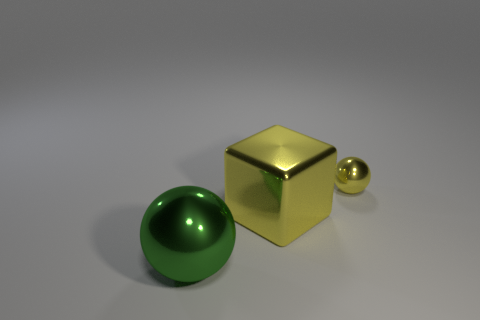How many other green shiny balls have the same size as the green sphere?
Provide a succinct answer. 0. Are there more blue cylinders than big things?
Give a very brief answer. No. Does the tiny yellow object have the same shape as the large green metallic object?
Your answer should be very brief. Yes. Is there any other thing that has the same shape as the large green metallic thing?
Keep it short and to the point. Yes. There is a metal object to the right of the yellow block; does it have the same color as the big metallic object behind the green sphere?
Provide a short and direct response. Yes. Is the number of large cubes that are left of the big green thing less than the number of metal spheres to the right of the metallic cube?
Give a very brief answer. Yes. There is a large yellow object that is to the left of the small yellow shiny object; what is its shape?
Your answer should be very brief. Cube. There is a small object that is the same color as the big block; what is its material?
Offer a terse response. Metal. There is a small thing; is it the same shape as the big object in front of the large block?
Offer a very short reply. Yes. There is a big yellow object that is the same material as the green object; what is its shape?
Your answer should be compact. Cube. 